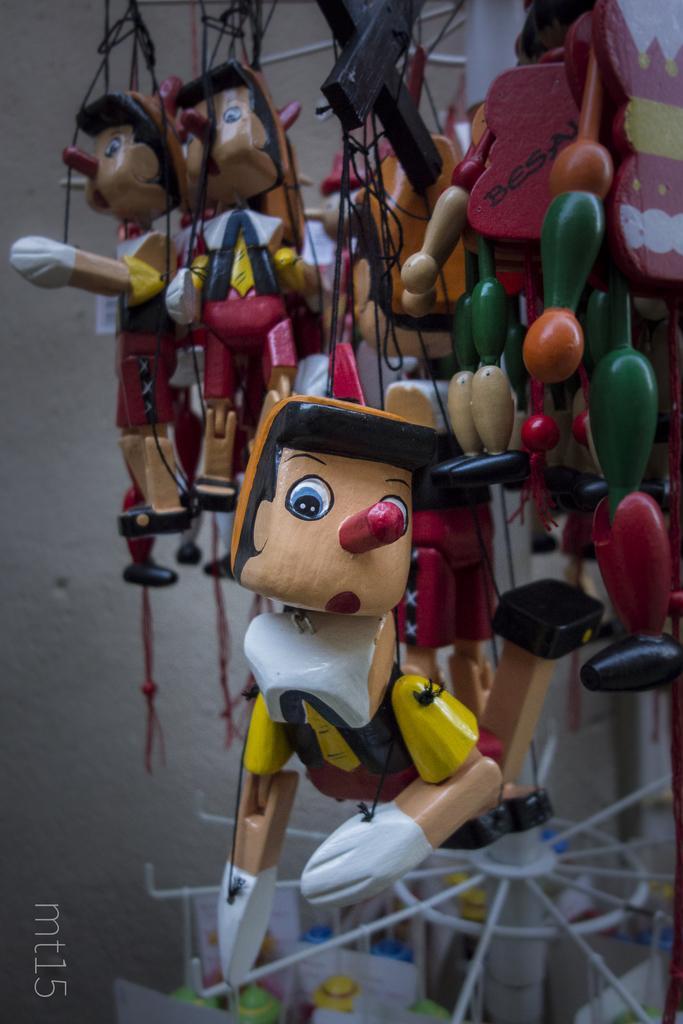How would you summarize this image in a sentence or two? In this image I can see few puppets and black colour ropes. I can also see watermark over here and few colourful things in background. 